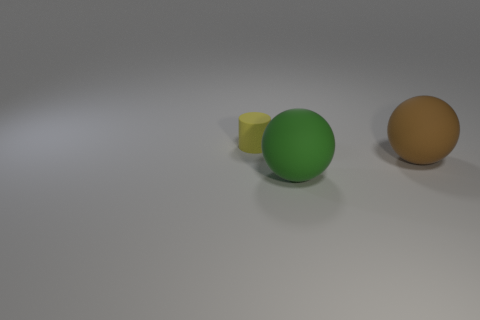Add 1 yellow matte cylinders. How many objects exist? 4 Subtract all cylinders. How many objects are left? 2 Add 3 large green matte balls. How many large green matte balls exist? 4 Subtract 0 yellow cubes. How many objects are left? 3 Subtract all tiny yellow metal balls. Subtract all large spheres. How many objects are left? 1 Add 3 small yellow rubber objects. How many small yellow rubber objects are left? 4 